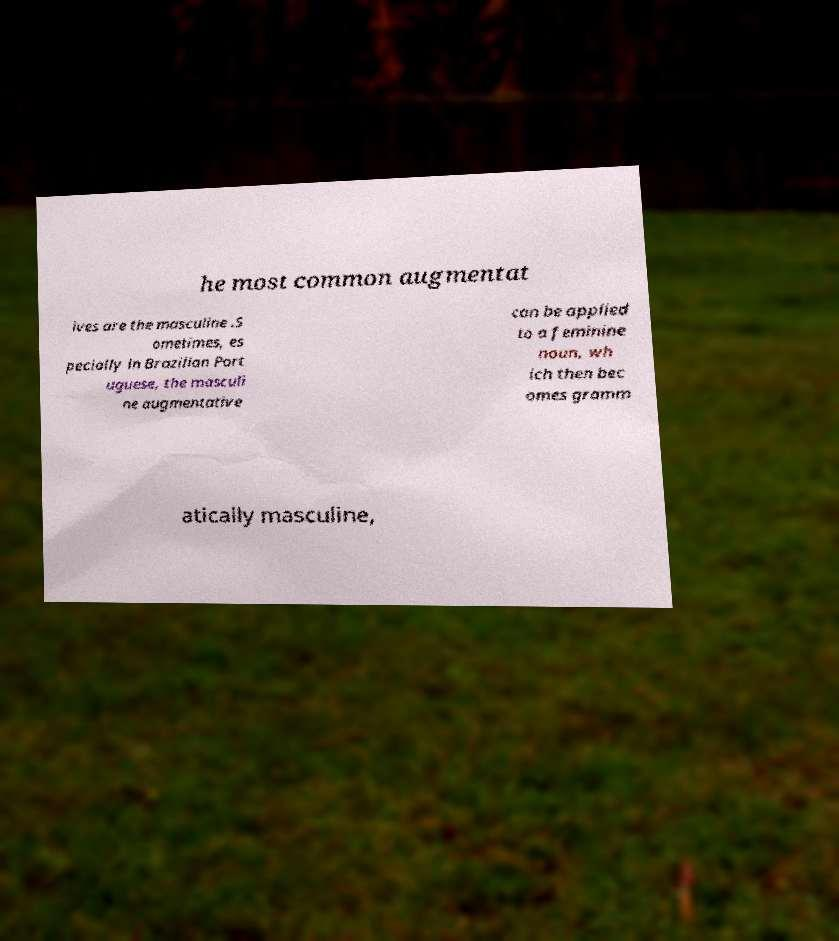Can you read and provide the text displayed in the image?This photo seems to have some interesting text. Can you extract and type it out for me? he most common augmentat ives are the masculine .S ometimes, es pecially in Brazilian Port uguese, the masculi ne augmentative can be applied to a feminine noun, wh ich then bec omes gramm atically masculine, 